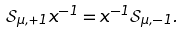<formula> <loc_0><loc_0><loc_500><loc_500>\mathcal { S } _ { \mu , + 1 } x ^ { - 1 } = x ^ { - 1 } \mathcal { S } _ { \mu , - 1 } .</formula> 